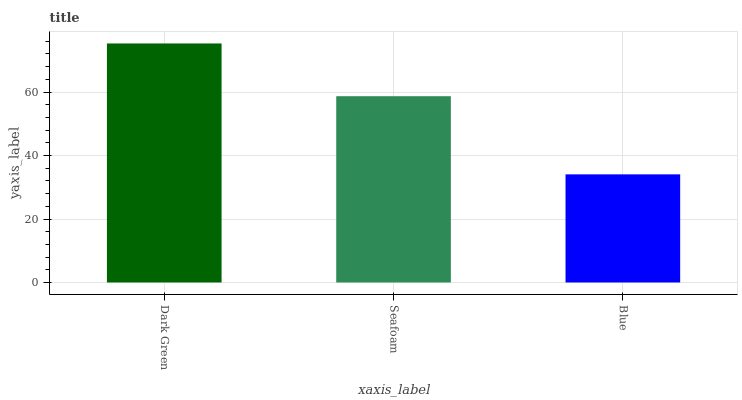Is Blue the minimum?
Answer yes or no. Yes. Is Dark Green the maximum?
Answer yes or no. Yes. Is Seafoam the minimum?
Answer yes or no. No. Is Seafoam the maximum?
Answer yes or no. No. Is Dark Green greater than Seafoam?
Answer yes or no. Yes. Is Seafoam less than Dark Green?
Answer yes or no. Yes. Is Seafoam greater than Dark Green?
Answer yes or no. No. Is Dark Green less than Seafoam?
Answer yes or no. No. Is Seafoam the high median?
Answer yes or no. Yes. Is Seafoam the low median?
Answer yes or no. Yes. Is Blue the high median?
Answer yes or no. No. Is Dark Green the low median?
Answer yes or no. No. 